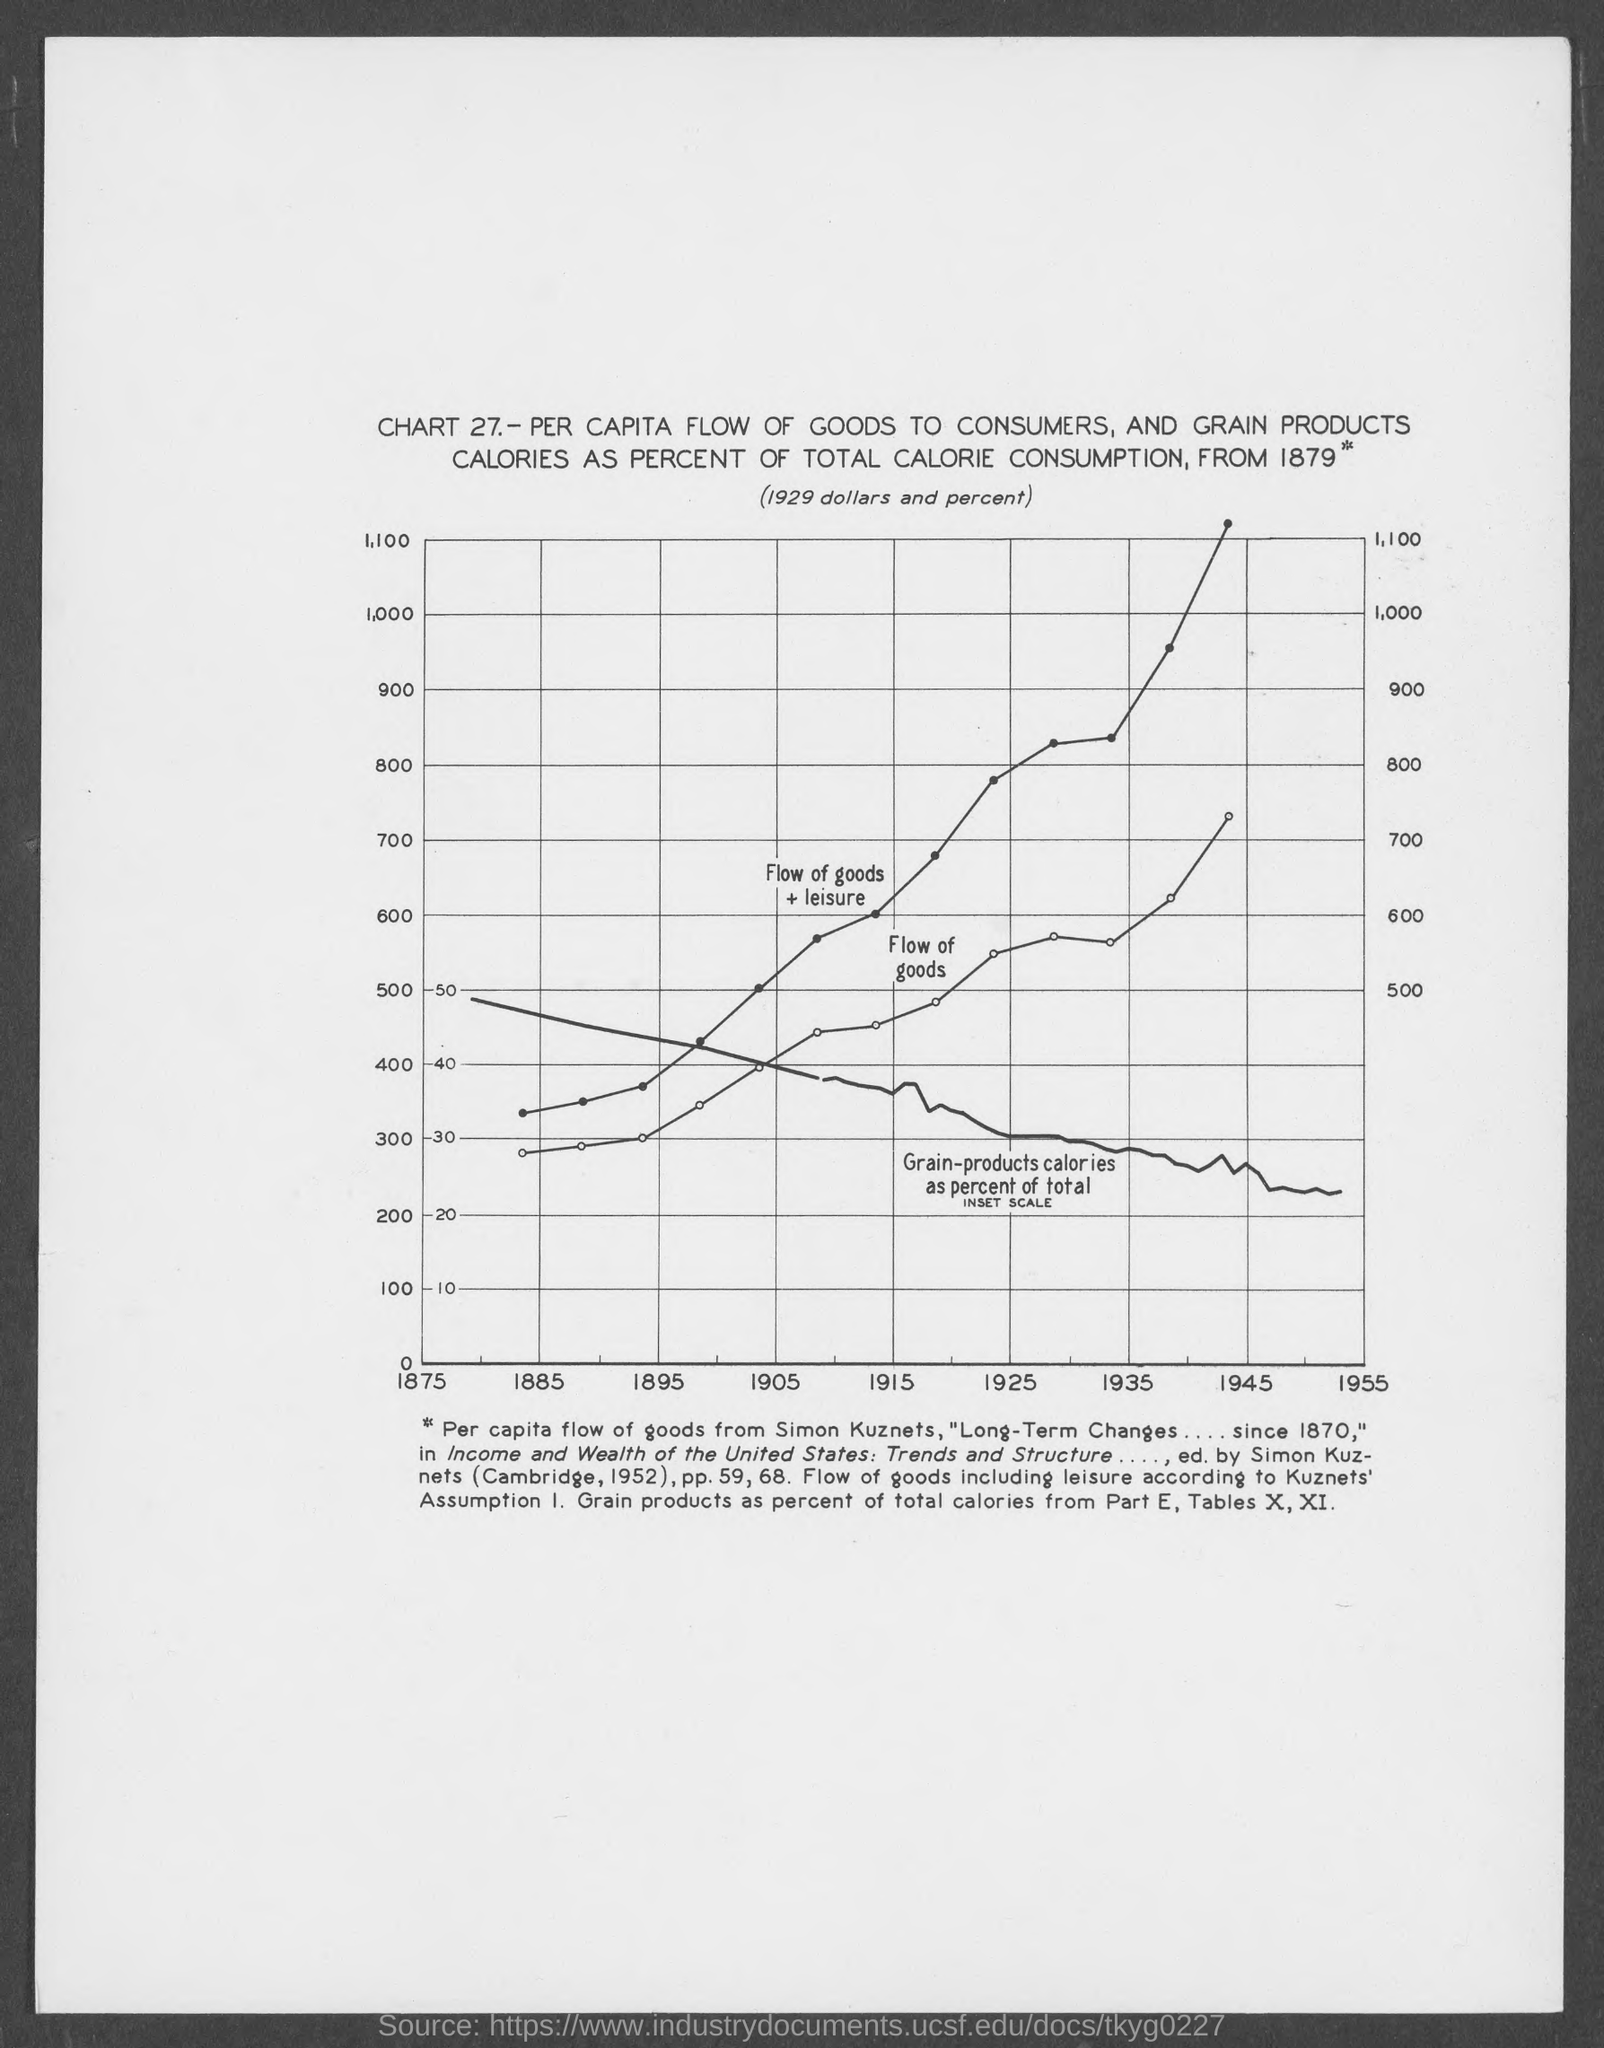What is the chart number?
Give a very brief answer. 27. What is the chart title?
Keep it short and to the point. Per capita flow of goods to consumers, and grain products calories as percent of total calorie consumption, from 1879*. Which year is mentioned first on x-axis?
Offer a very short reply. 1875. 